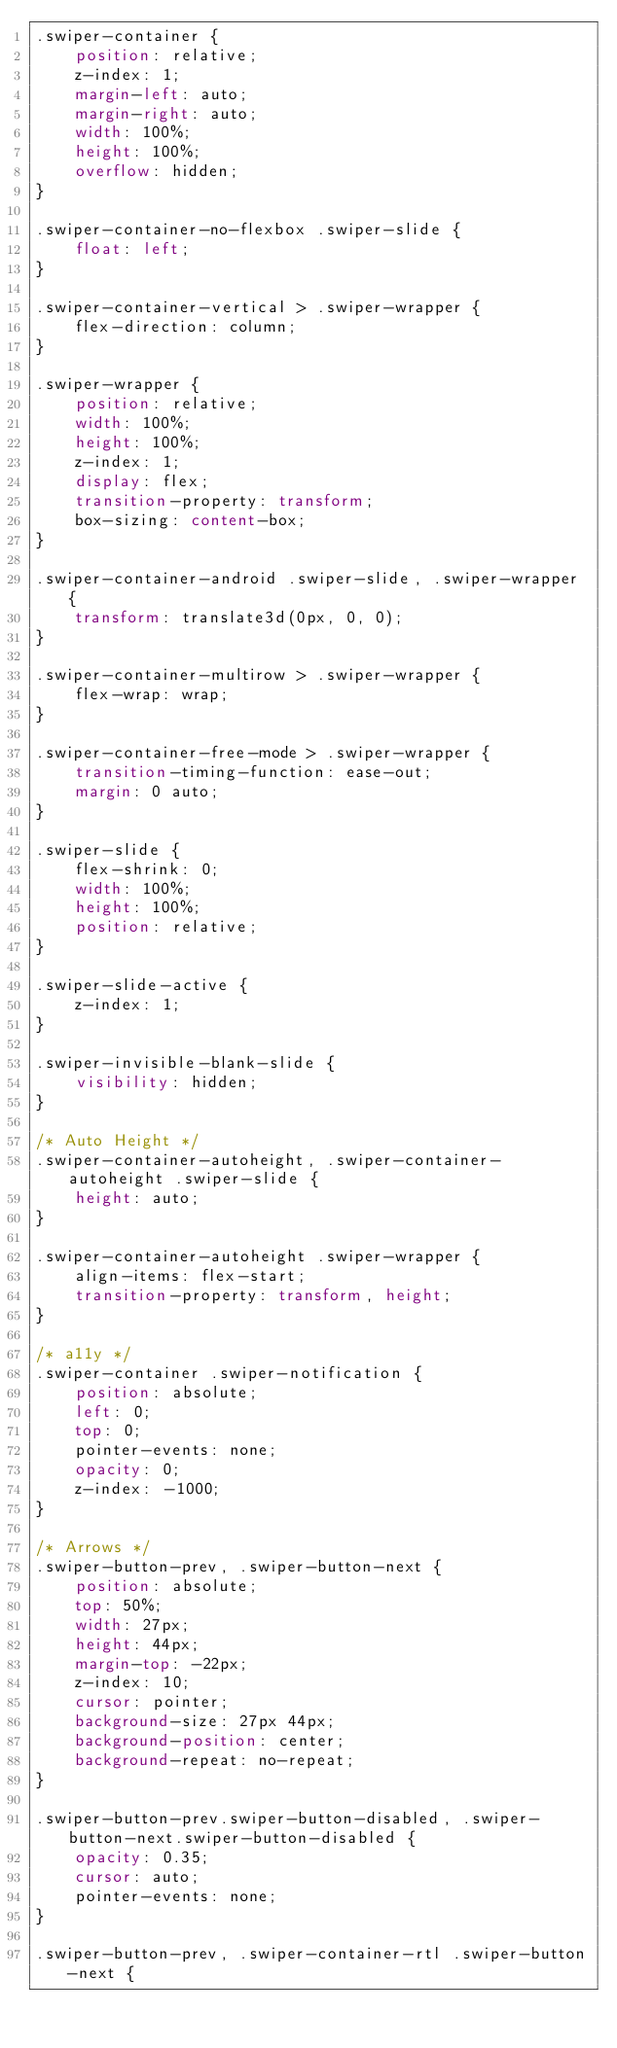Convert code to text. <code><loc_0><loc_0><loc_500><loc_500><_CSS_>.swiper-container {
    position: relative;
    z-index: 1;
    margin-left: auto;
    margin-right: auto;
    width: 100%;
    height: 100%;
    overflow: hidden;
}

.swiper-container-no-flexbox .swiper-slide {
    float: left;
}

.swiper-container-vertical > .swiper-wrapper {
    flex-direction: column;
}

.swiper-wrapper {
    position: relative;
    width: 100%;
    height: 100%;
    z-index: 1;
    display: flex;
    transition-property: transform;
    box-sizing: content-box;
}

.swiper-container-android .swiper-slide, .swiper-wrapper {
    transform: translate3d(0px, 0, 0);
}

.swiper-container-multirow > .swiper-wrapper {
    flex-wrap: wrap;
}

.swiper-container-free-mode > .swiper-wrapper {
    transition-timing-function: ease-out;
    margin: 0 auto;
}

.swiper-slide {
    flex-shrink: 0;
    width: 100%;
    height: 100%;
    position: relative;
}

.swiper-slide-active {
    z-index: 1;
}

.swiper-invisible-blank-slide {
    visibility: hidden;
}

/* Auto Height */
.swiper-container-autoheight, .swiper-container-autoheight .swiper-slide {
    height: auto;
}

.swiper-container-autoheight .swiper-wrapper {
    align-items: flex-start;
    transition-property: transform, height;
}

/* a11y */
.swiper-container .swiper-notification {
    position: absolute;
    left: 0;
    top: 0;
    pointer-events: none;
    opacity: 0;
    z-index: -1000;
}

/* Arrows */
.swiper-button-prev, .swiper-button-next {
    position: absolute;
    top: 50%;
    width: 27px;
    height: 44px;
    margin-top: -22px;
    z-index: 10;
    cursor: pointer;
    background-size: 27px 44px;
    background-position: center;
    background-repeat: no-repeat;
}

.swiper-button-prev.swiper-button-disabled, .swiper-button-next.swiper-button-disabled {
    opacity: 0.35;
    cursor: auto;
    pointer-events: none;
}

.swiper-button-prev, .swiper-container-rtl .swiper-button-next {</code> 